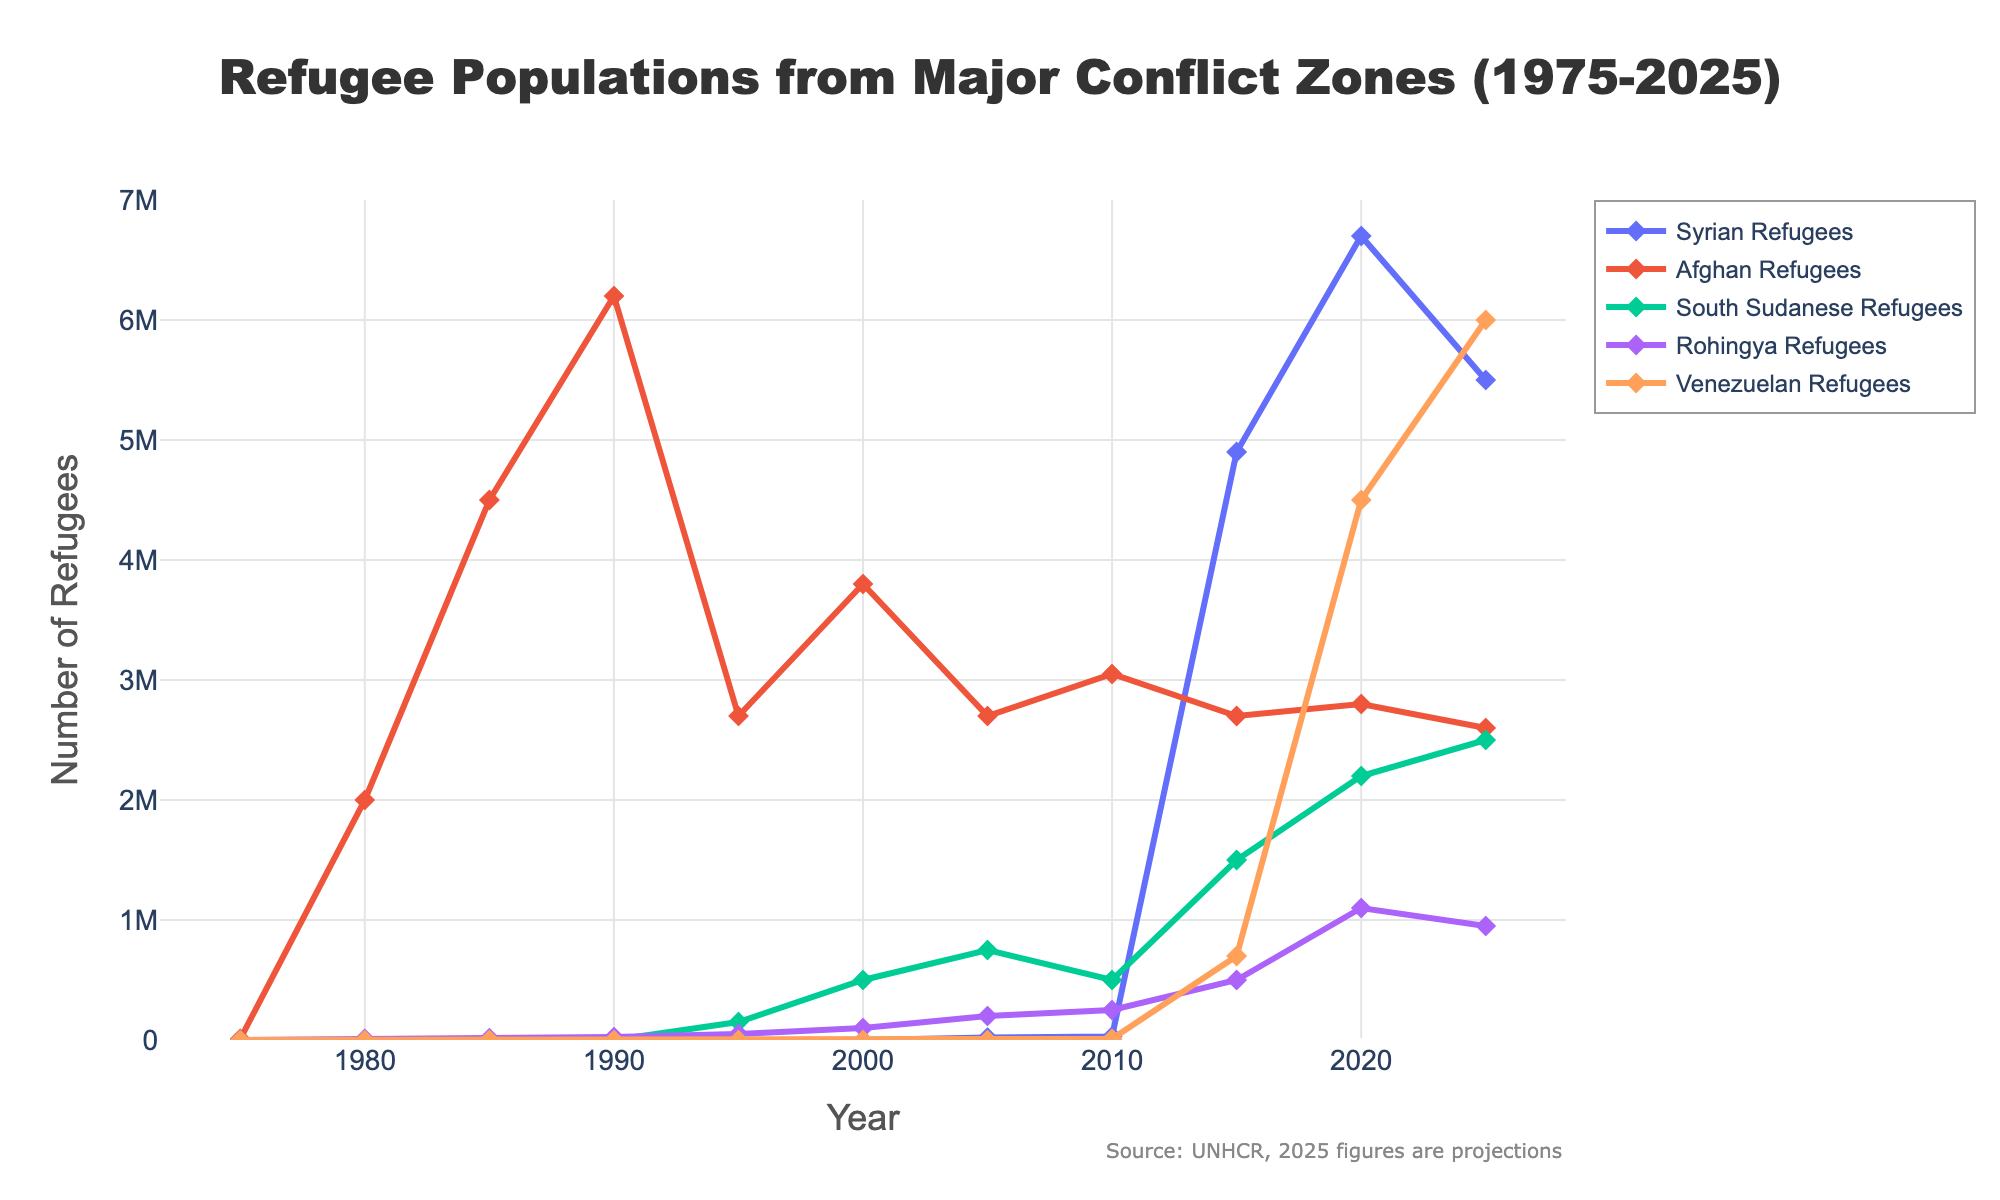what is the maximum number of Syrian refugees and in which year? The highest point for the Syrian Refugees line is in the year 2020 at 6,700,000.
Answer: 6,700,000 in 2020 How has the population of Afghan refugees changed from 1980 to 2000? In 1980, there were 2,000,000 Afghan refugees. By 2000, this number increased to 3,800,000. The difference is 3,800,000 - 2,000,000 = 1,800,000.
Answer: Increased by 1,800,000 Which group showed the highest increase in population between 2015 and 2020? Comparing the populations for each group between 2015 and 2020, Venezuelan refugees increased from 700,000 to 4,500,000, a difference of 3,800,000. This is the highest increase among all groups.
Answer: Venezuelan refugees by 3,800,000 In which year did the population of South Sudanese refugees first exceed 1,000,000? The population of South Sudanese refugees first exceeds 1,000,000 in the year 2015, when it reaches 1,500,000.
Answer: 2015 What is the total number of refugees from Afghanistan and South Sudan in 2020? The number of Afghan refugees in 2020 is 2,800,000 and for South Sudanese refugees it is 2,200,000. Their total is 2,800,000 + 2,200,000 = 5,000,000.
Answer: 5,000,000 Compare the population of Rohingya refugees in 1995 and 2020. Which year had more and by how much? In 1995, the Rohingya refugee population was 50,000. In 2020, it increased to 1,100,000. The difference is 1,100,000 - 50,000 = 1,050,000.
Answer: 2020 by 1,050,000 What trend is visible in Venezuelan refugees from 2010 to 2025? The Venezuelan refugee population starts at 10,000 in 2010, rises to 700,000 in 2015, 4,500,000 in 2020, and reaches 6,000,000 by 2025, showing a clear increasing trend.
Answer: Increasing trend Which group had the smallest population of refugees in 1990? By looking at the data for 1990, the Rohingya refugees had a population of 25,000, which is the lowest among all groups in that year.
Answer: Rohingya refugees How does the number of Afghan refugees in 2025 compare to the number in 2000? The number of Afghan refugees was 3,800,000 in 2000 and decreased to 2,600,000 in 2025, showing a reduction of 3,800,000 - 2,600,000 = 1,200,000.
Answer: Decreased by 1,200,000 What is the average number of South Sudanese refugees from 2000 to 2025? The number of South Sudanese refugees over the years 2000, 2005, 2010, 2015, 2020, and 2025 are 500,000, 750,000, 500,000, 1,500,000, 2,200,000, and 2,500,000 respectively. The average is calculated as (500,000 + 750,000 + 500,000 + 1,500,000 + 2,200,000 + 2,500,000) / 6 = 1,325,000.
Answer: 1,325,000 